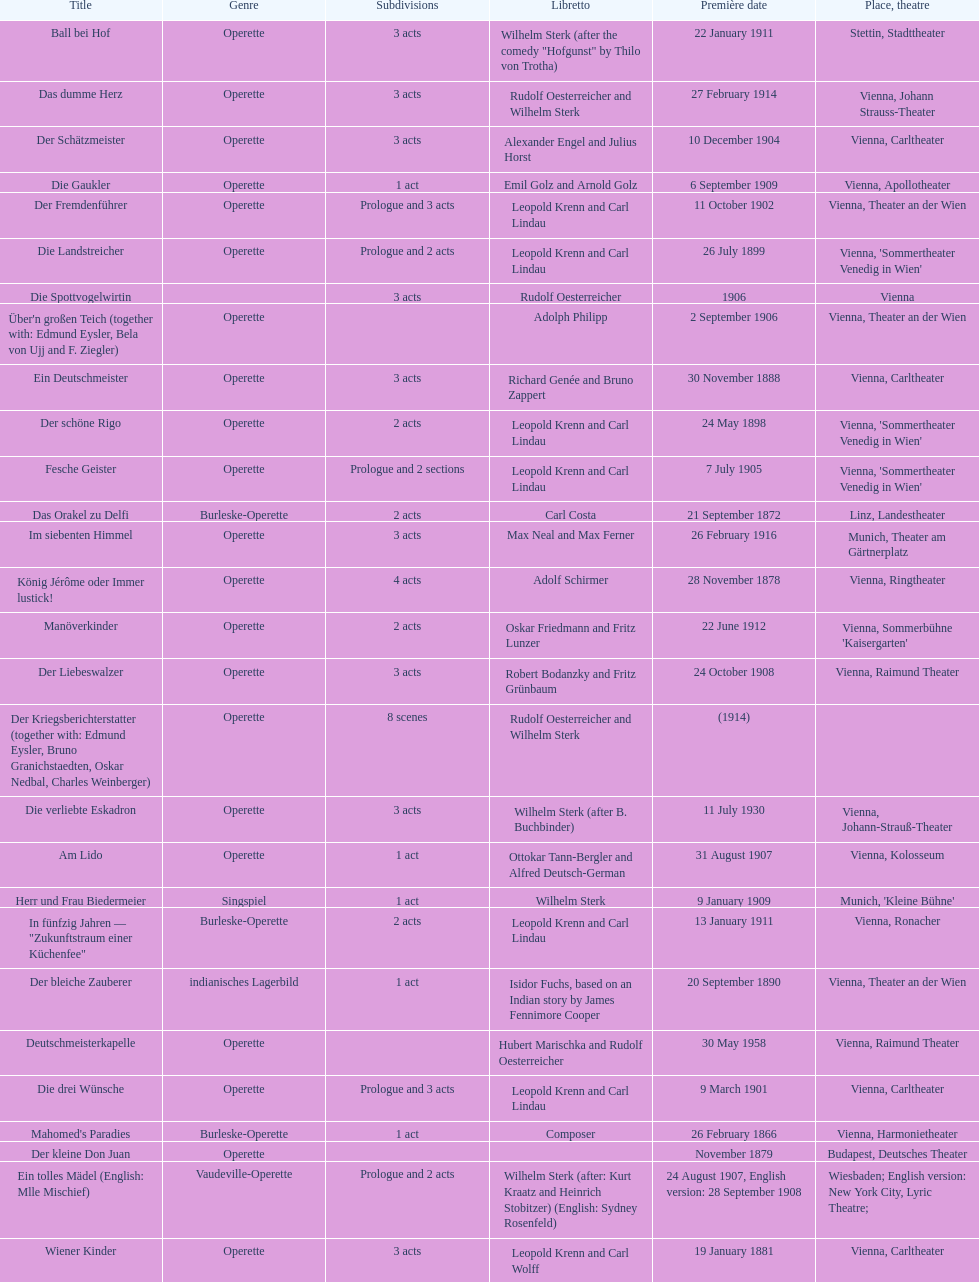What was the year of the last title? 1958. 